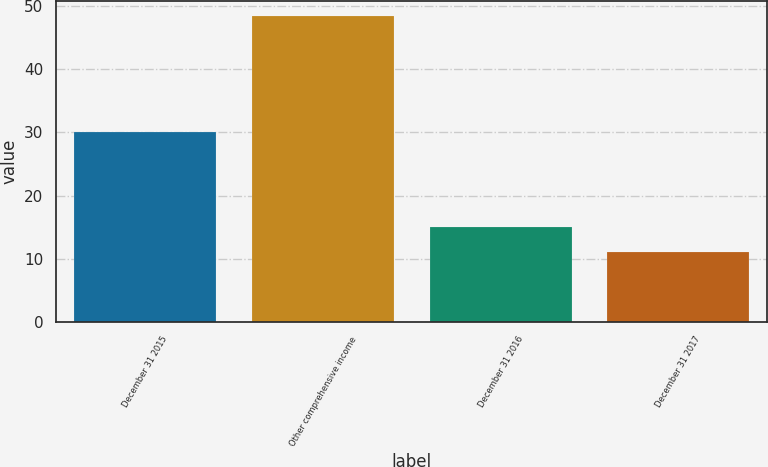Convert chart. <chart><loc_0><loc_0><loc_500><loc_500><bar_chart><fcel>December 31 2015<fcel>Other comprehensive income<fcel>December 31 2016<fcel>December 31 2017<nl><fcel>30<fcel>48.4<fcel>15<fcel>11<nl></chart> 